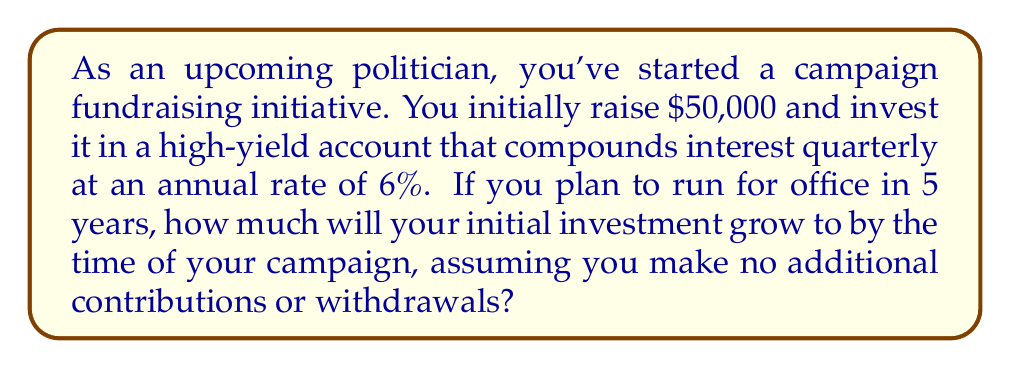Show me your answer to this math problem. To solve this problem, we'll use the compound interest formula:

$$A = P(1 + \frac{r}{n})^{nt}$$

Where:
$A$ = final amount
$P$ = principal (initial investment)
$r$ = annual interest rate (as a decimal)
$n$ = number of times interest is compounded per year
$t$ = number of years

Given:
$P = \$50,000$
$r = 0.06$ (6% expressed as a decimal)
$n = 4$ (compounded quarterly)
$t = 5$ years

Let's substitute these values into the formula:

$$A = 50000(1 + \frac{0.06}{4})^{4 \cdot 5}$$

$$A = 50000(1 + 0.015)^{20}$$

$$A = 50000(1.015)^{20}$$

Using a calculator or computer:

$$A = 50000 \cdot 1.3488539$$

$$A = 67442.70$$
Answer: $67,442.70 